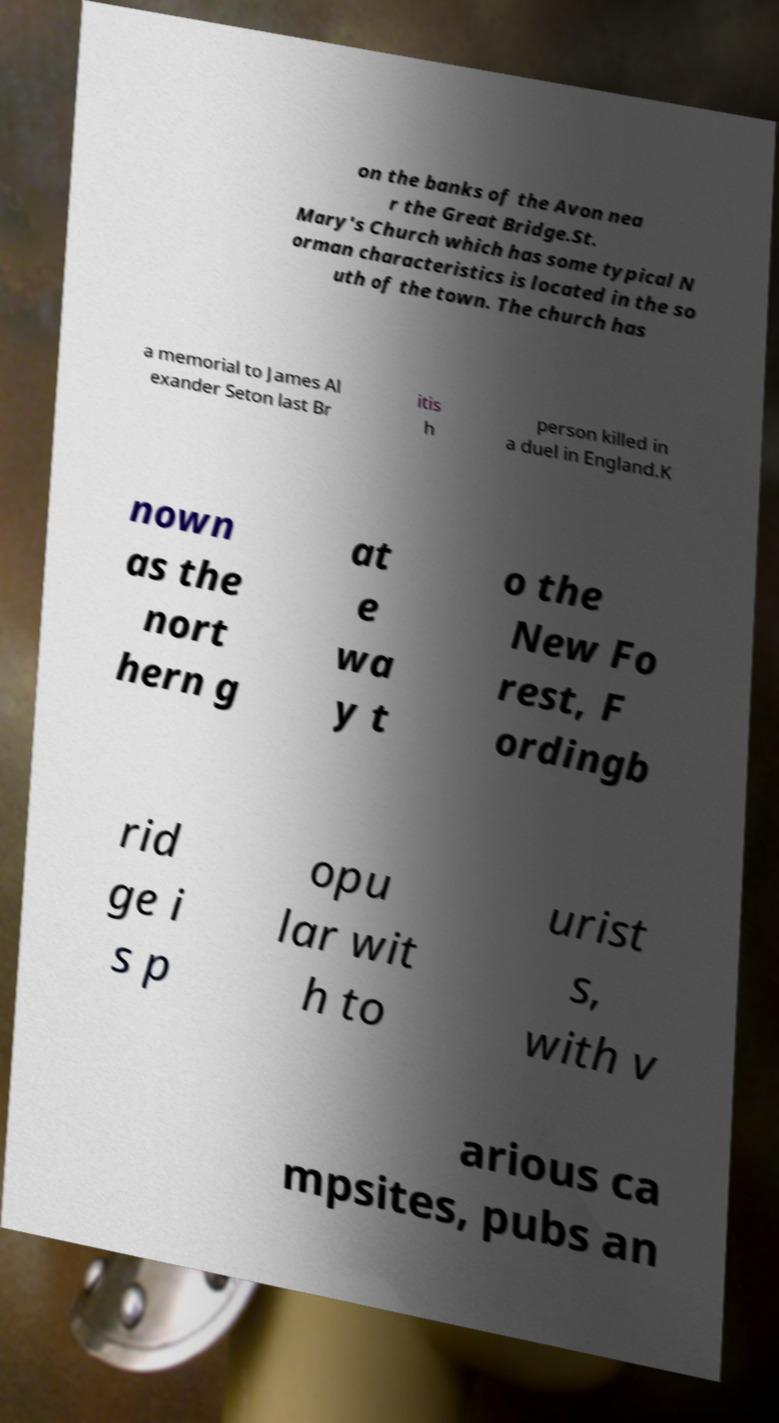What messages or text are displayed in this image? I need them in a readable, typed format. on the banks of the Avon nea r the Great Bridge.St. Mary's Church which has some typical N orman characteristics is located in the so uth of the town. The church has a memorial to James Al exander Seton last Br itis h person killed in a duel in England.K nown as the nort hern g at e wa y t o the New Fo rest, F ordingb rid ge i s p opu lar wit h to urist s, with v arious ca mpsites, pubs an 